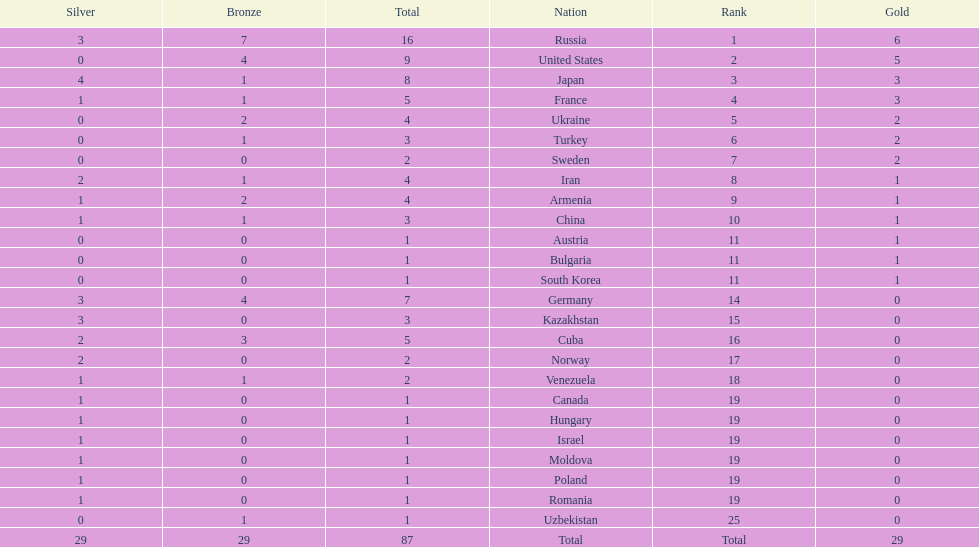Which country won only one medal, a bronze medal? Uzbekistan. 